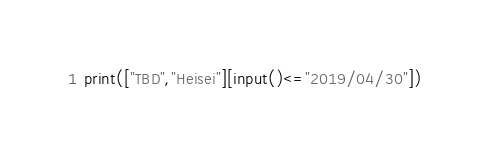Convert code to text. <code><loc_0><loc_0><loc_500><loc_500><_Python_>print(["TBD","Heisei"][input()<="2019/04/30"])</code> 